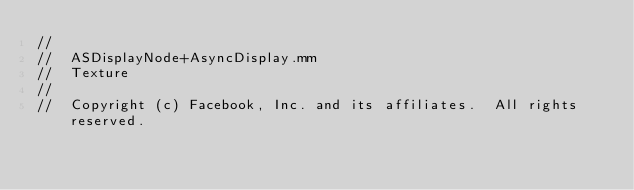Convert code to text. <code><loc_0><loc_0><loc_500><loc_500><_ObjectiveC_>//
//  ASDisplayNode+AsyncDisplay.mm
//  Texture
//
//  Copyright (c) Facebook, Inc. and its affiliates.  All rights reserved.</code> 